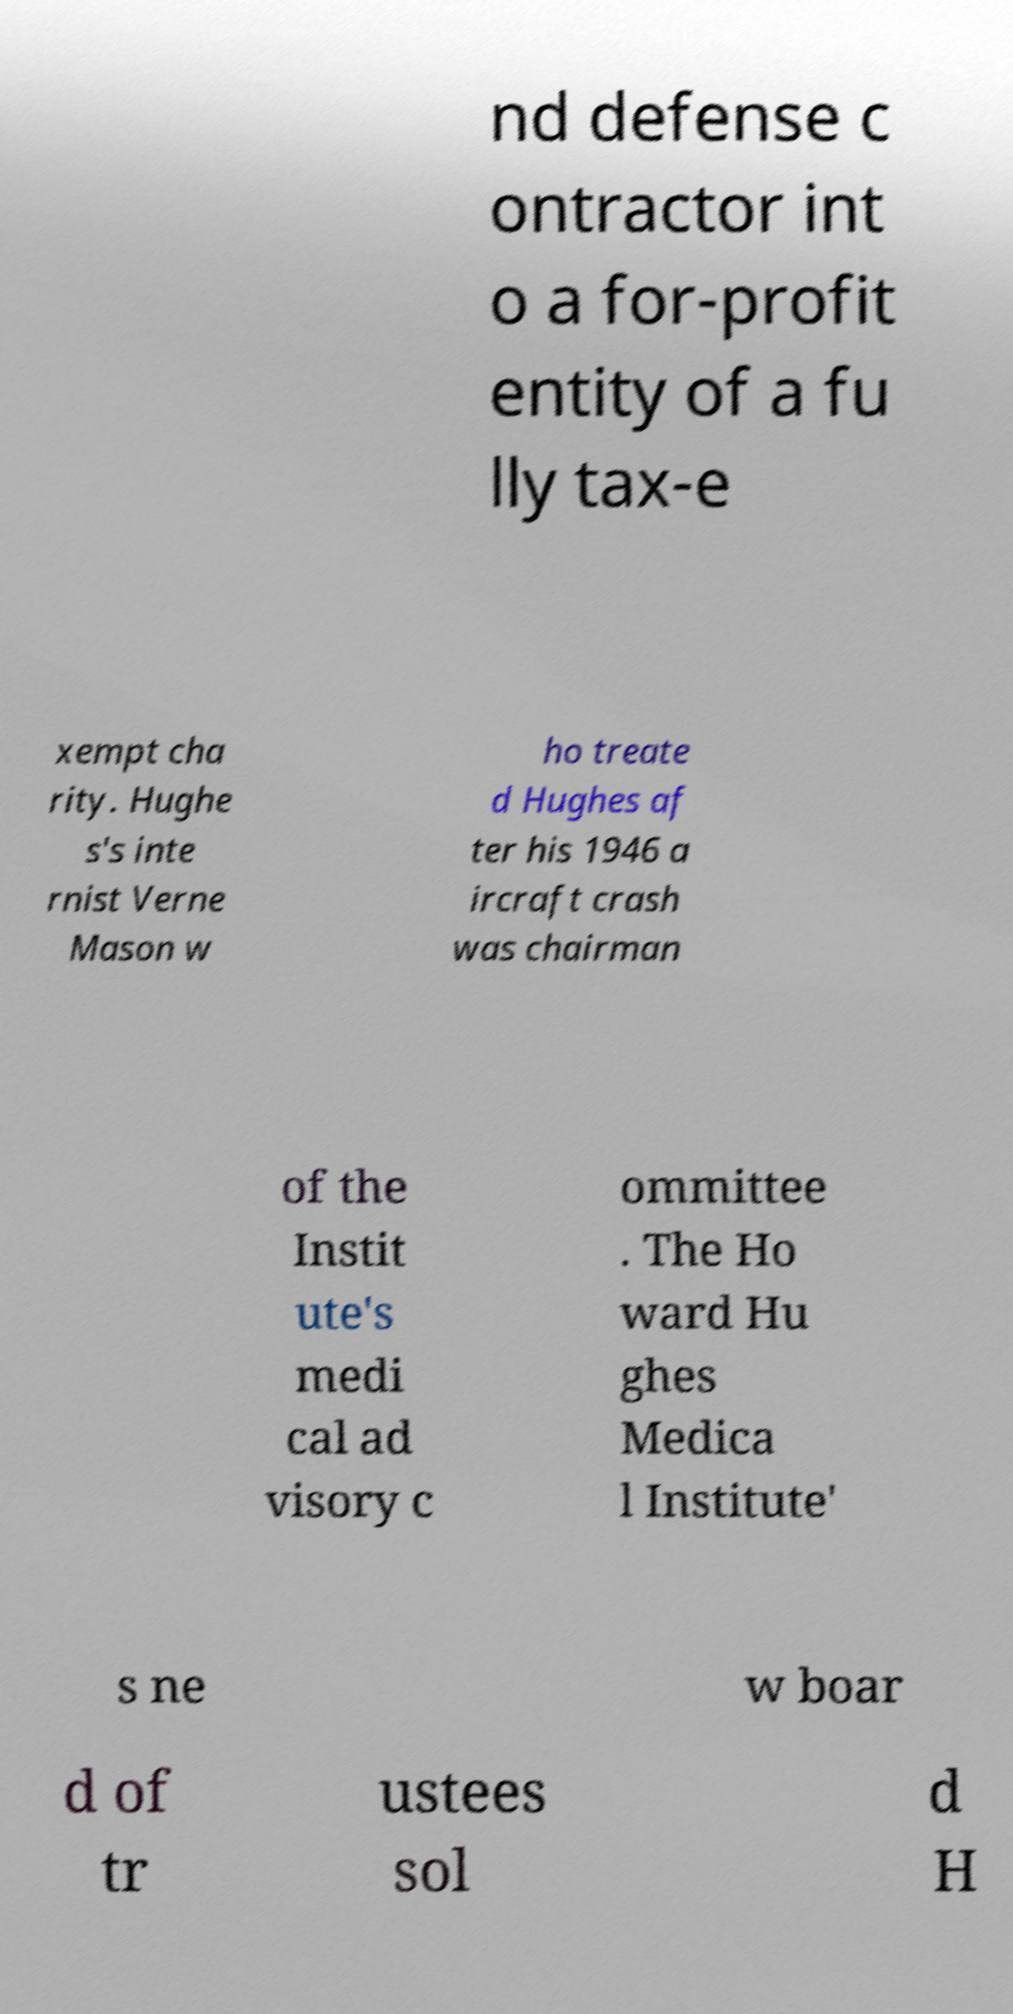Can you read and provide the text displayed in the image?This photo seems to have some interesting text. Can you extract and type it out for me? nd defense c ontractor int o a for-profit entity of a fu lly tax-e xempt cha rity. Hughe s's inte rnist Verne Mason w ho treate d Hughes af ter his 1946 a ircraft crash was chairman of the Instit ute's medi cal ad visory c ommittee . The Ho ward Hu ghes Medica l Institute' s ne w boar d of tr ustees sol d H 